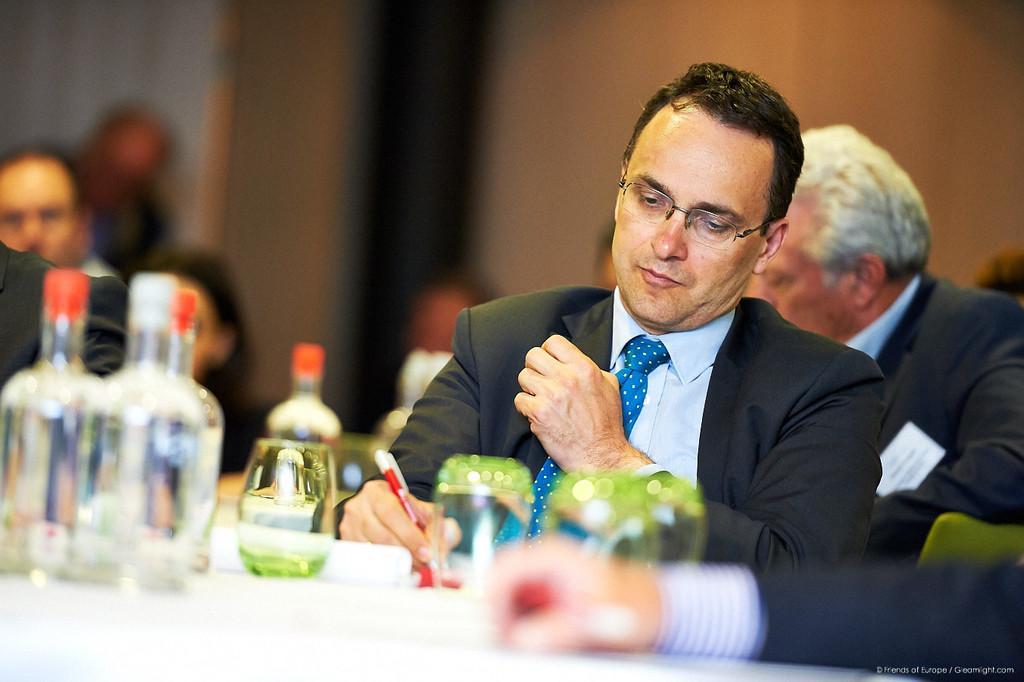Can you describe this image briefly? In this picture we can see man wore blazer, tie, spectacle writing with pen on paper placed on a table and we have bottles, glass on same table and in background we can see some more persons and it is blur. 